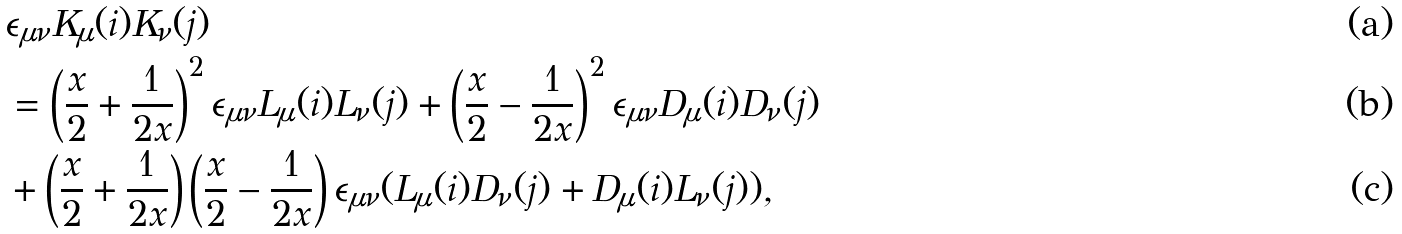Convert formula to latex. <formula><loc_0><loc_0><loc_500><loc_500>& \epsilon _ { \mu \nu } K _ { \mu } ( i ) K _ { \nu } ( j ) \\ & = \left ( \frac { x } { 2 } + \frac { 1 } { 2 x } \right ) ^ { 2 } \epsilon _ { \mu \nu } L _ { \mu } ( i ) L _ { \nu } ( j ) + \left ( \frac { x } { 2 } - \frac { 1 } { 2 x } \right ) ^ { 2 } \epsilon _ { \mu \nu } D _ { \mu } ( i ) D _ { \nu } ( j ) \\ & + \left ( \frac { x } { 2 } + \frac { 1 } { 2 x } \right ) \left ( \frac { x } { 2 } - \frac { 1 } { 2 x } \right ) \epsilon _ { \mu \nu } ( L _ { \mu } ( i ) D _ { \nu } ( j ) + D _ { \mu } ( i ) L _ { \nu } ( j ) ) ,</formula> 